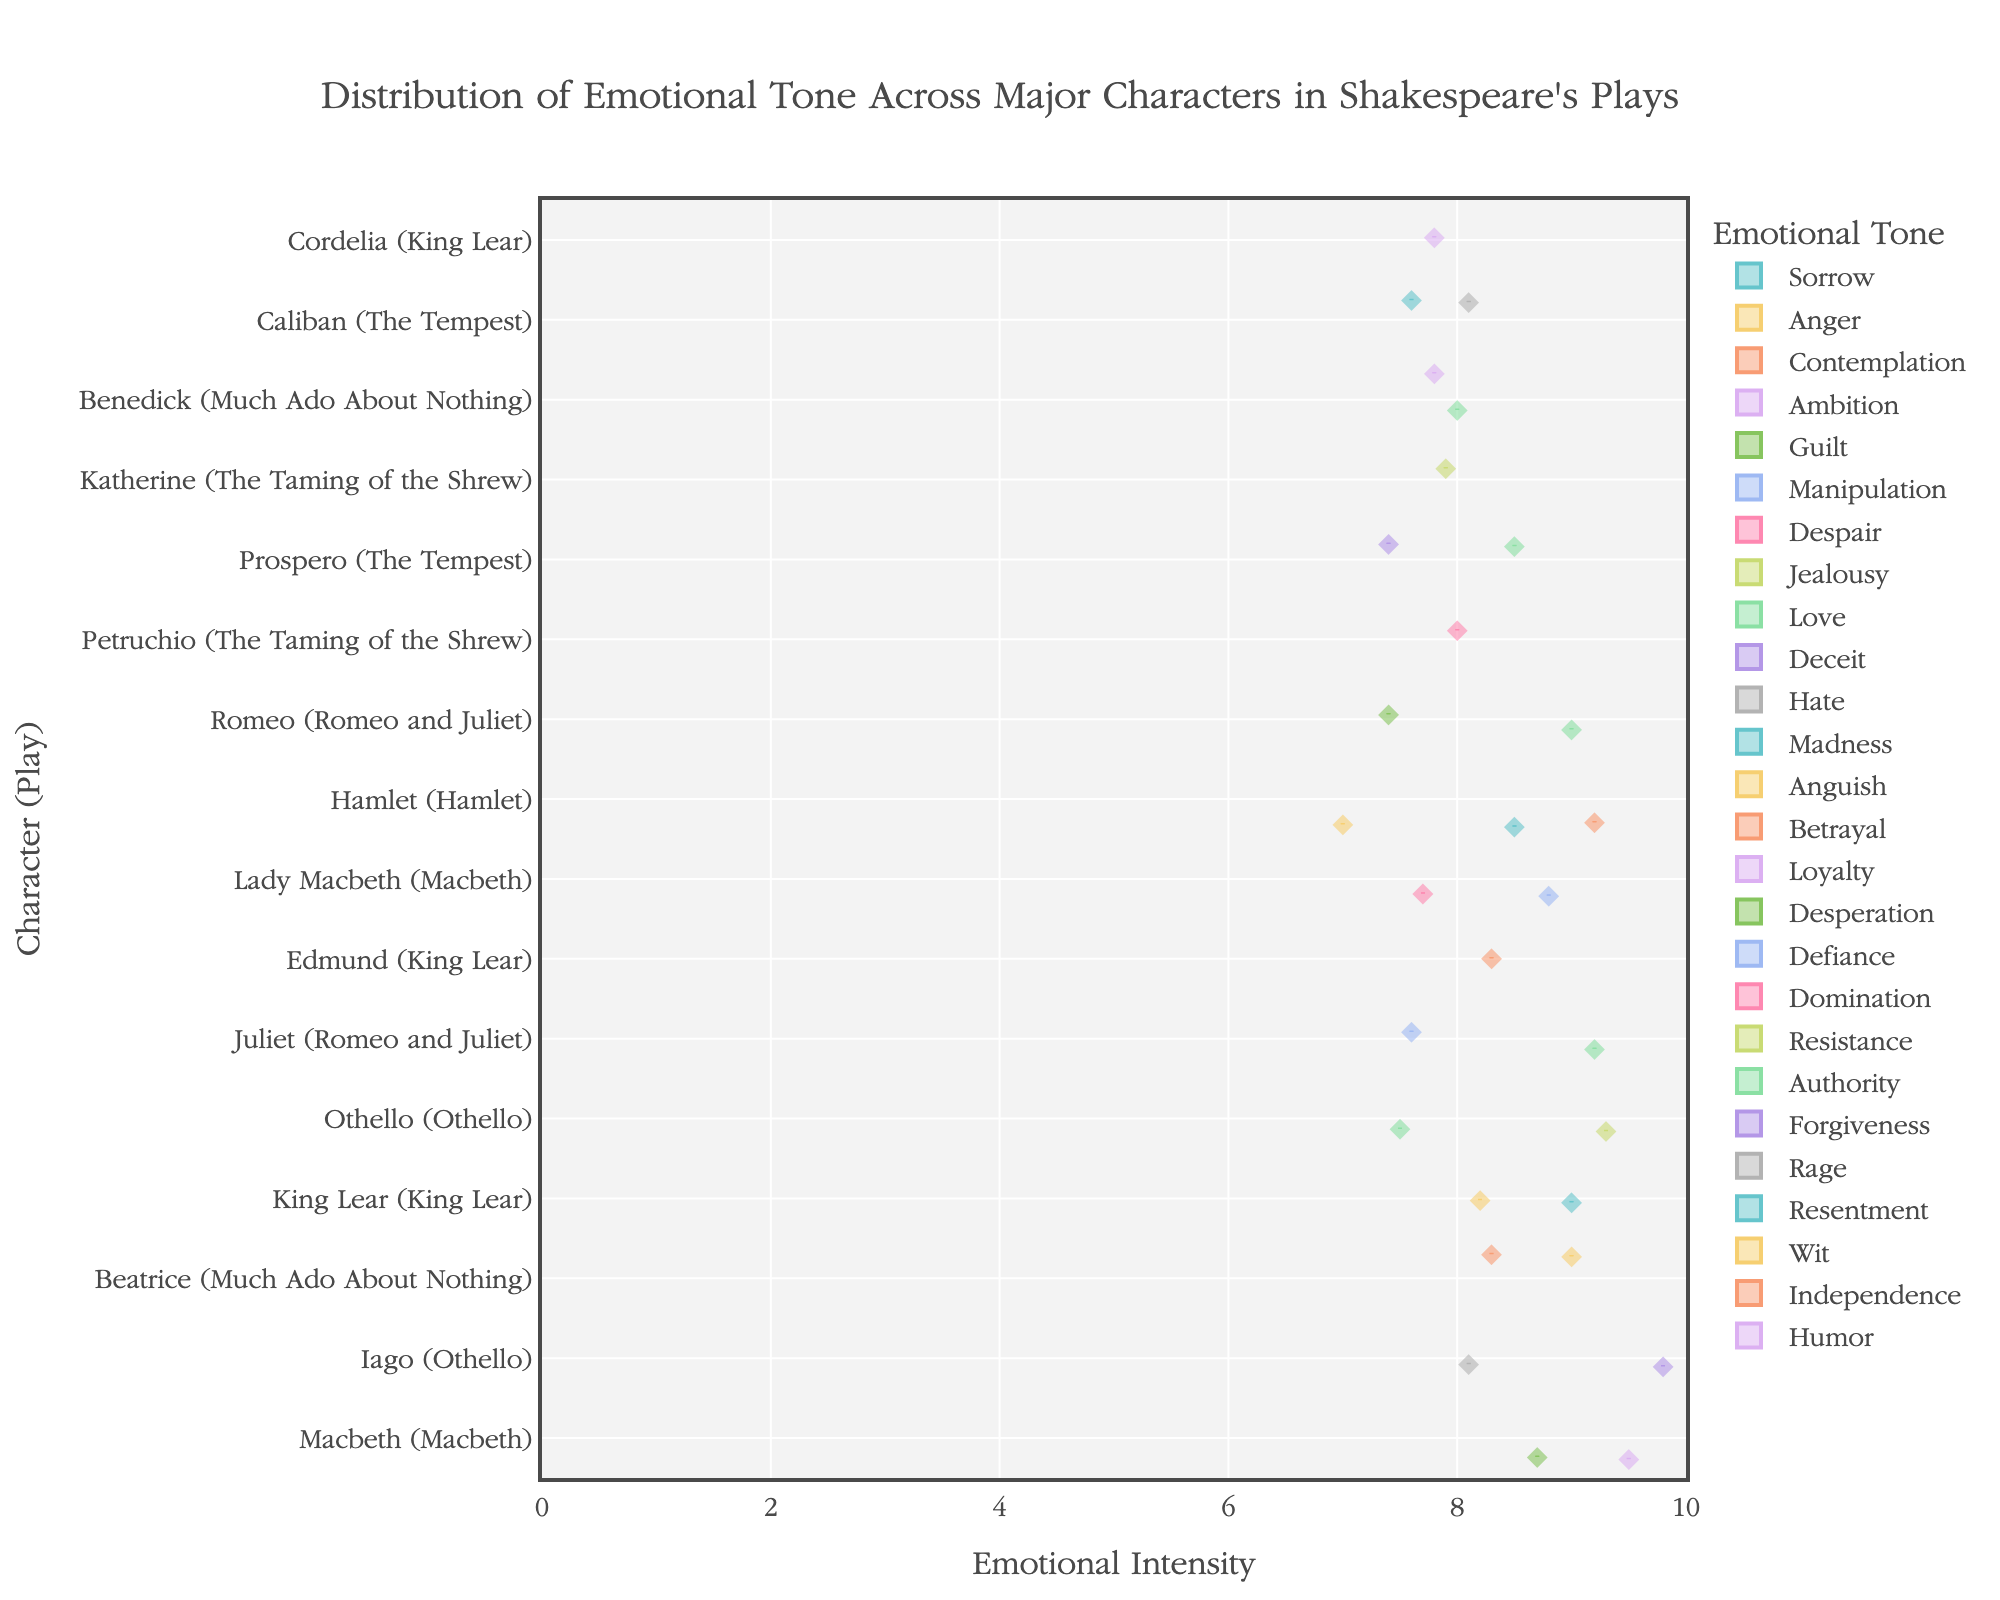What is the title of the figure? The title is typically displayed at the top of the chart and provides an overview of the data being presented.
Answer: Distribution of Emotional Tone Across Major Characters in Shakespeare's Plays Which character exhibits the highest intensity of Ambition? By observing the violin plots, the character with Ambition as an emotional tone can be identified. The highest point of intensity for that section shows the character with the highest intensity.
Answer: Macbeth How many emotional tones are depicted for Juliet (Romeo and Juliet)? Each character has several emotional tones represented by different violin plots. Count the number of different emotional tones associated with Juliet's section.
Answer: 2 Which character in "Much Ado About Nothing" shows the highest intensity and for which emotional tone? Look for characters from "Much Ado About Nothing" and identify their highest points. Check the corresponding emotional tone for that highest point.
Answer: Beatrice for Wit Between Hamlet and King Lear, which character shows a higher intensity for Anger? Identify the Anger violin plot for both Hamlet and King Lear. Compare the highest points of each plot to determine which one is higher.
Answer: Hamlet Comparing Guilt and Despair in "Macbeth," which emotional tone has a higher median intensity for Lady Macbeth? Examine the box plots within the violin plots for Guilt and Despair of Lady Macbeth. The median is the line inside the box plot. Compare the two.
Answer: Guilt How many different emotional tones are depicted across all characters? Count the number of unique emotional tones present across all characters depicted in the chart.
Answer: 20 What is the range of emotional intensity values for Romeo's Love in "Romeo and Juliet"? Identify the violin plot for Romeo's Love. The spread of the data points from the minimum to the maximum value represents the range.
Answer: 9.0 Who shows a higher intensity of Love: Romeo or Juliet? Compare the highest points in the Love violin plots for Romeo and Juliet.
Answer: Juliet What is the emotional tone with the highest intensity for Caliban in "The Tempest"? Identify Caliban's section, then find the highest point among the various emotional tones depicted.
Answer: Rage 